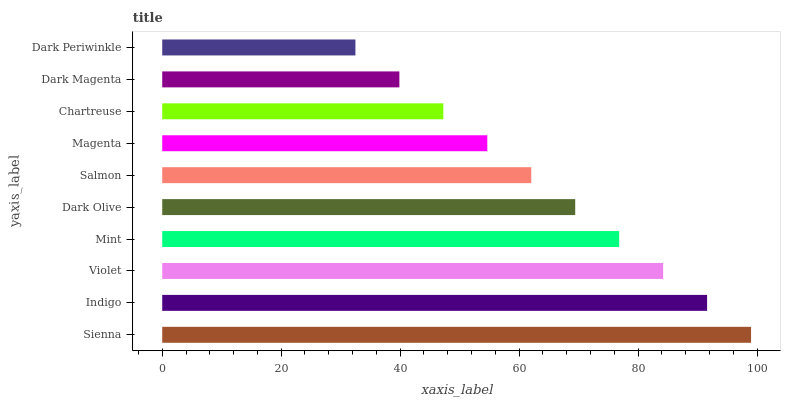Is Dark Periwinkle the minimum?
Answer yes or no. Yes. Is Sienna the maximum?
Answer yes or no. Yes. Is Indigo the minimum?
Answer yes or no. No. Is Indigo the maximum?
Answer yes or no. No. Is Sienna greater than Indigo?
Answer yes or no. Yes. Is Indigo less than Sienna?
Answer yes or no. Yes. Is Indigo greater than Sienna?
Answer yes or no. No. Is Sienna less than Indigo?
Answer yes or no. No. Is Dark Olive the high median?
Answer yes or no. Yes. Is Salmon the low median?
Answer yes or no. Yes. Is Chartreuse the high median?
Answer yes or no. No. Is Dark Periwinkle the low median?
Answer yes or no. No. 